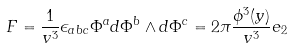<formula> <loc_0><loc_0><loc_500><loc_500>F = \frac { 1 } { v ^ { 3 } } \epsilon _ { a b c } \Phi ^ { a } d \Phi ^ { b } \wedge d \Phi ^ { c } = 2 \pi \frac { \phi ^ { 3 } ( y ) } { v ^ { 3 } } e _ { 2 }</formula> 